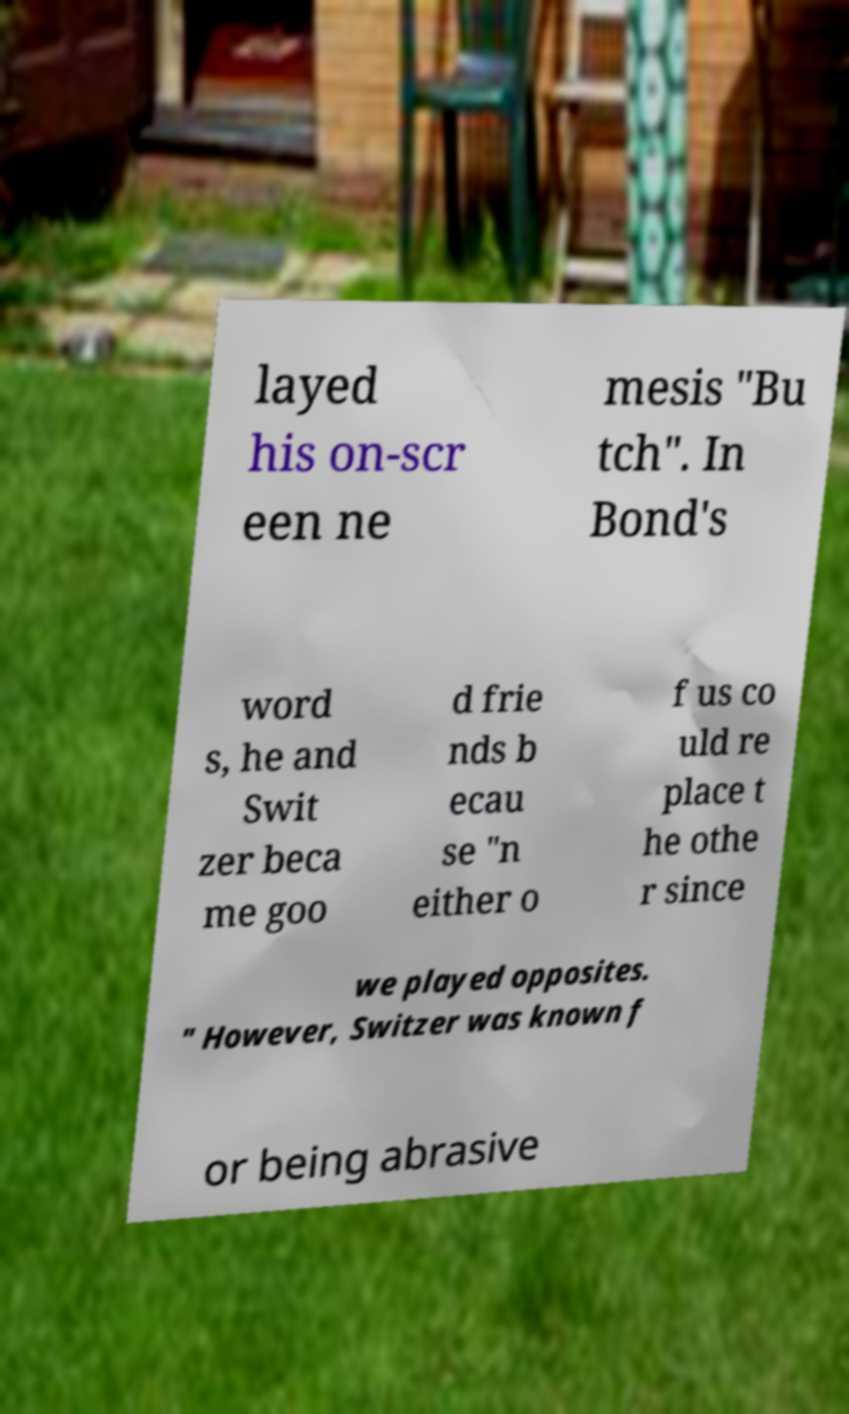What messages or text are displayed in this image? I need them in a readable, typed format. layed his on-scr een ne mesis "Bu tch". In Bond's word s, he and Swit zer beca me goo d frie nds b ecau se "n either o f us co uld re place t he othe r since we played opposites. " However, Switzer was known f or being abrasive 